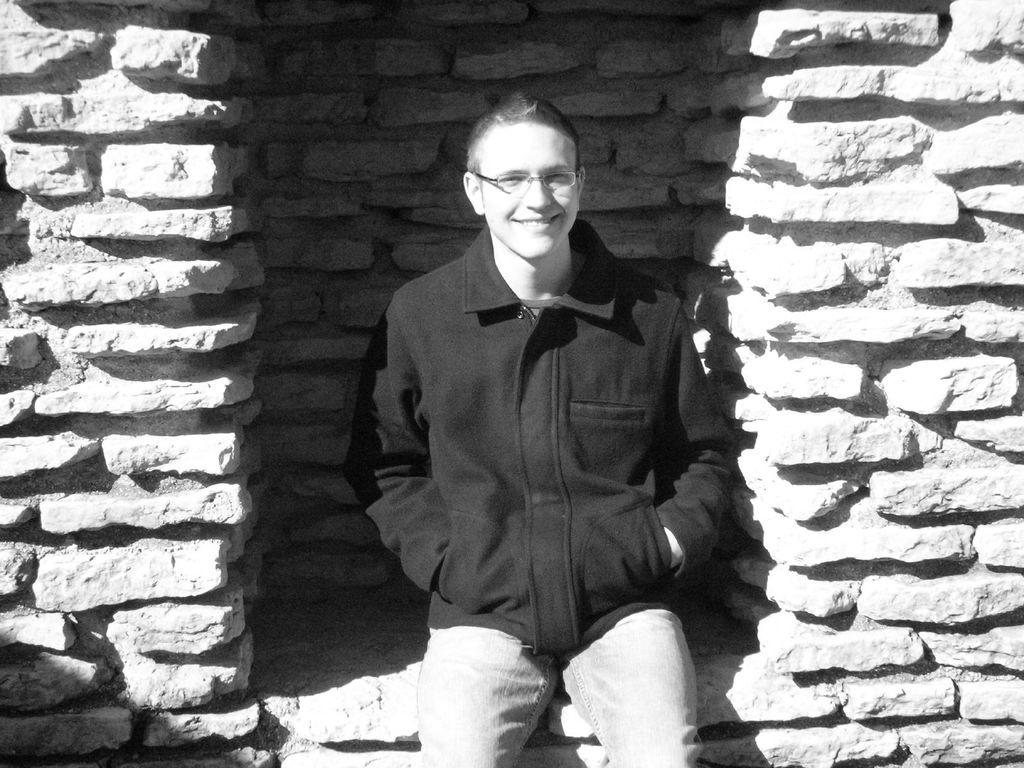Who is present in the image? There is a man in the image. What is the man wearing? The man is wearing a black jacket. What can be seen in the background of the image? There is a wall made up of rocks in the background of the image. Can you see a tiger's stomach in the image? There is no tiger or any part of a tiger present in the image. 